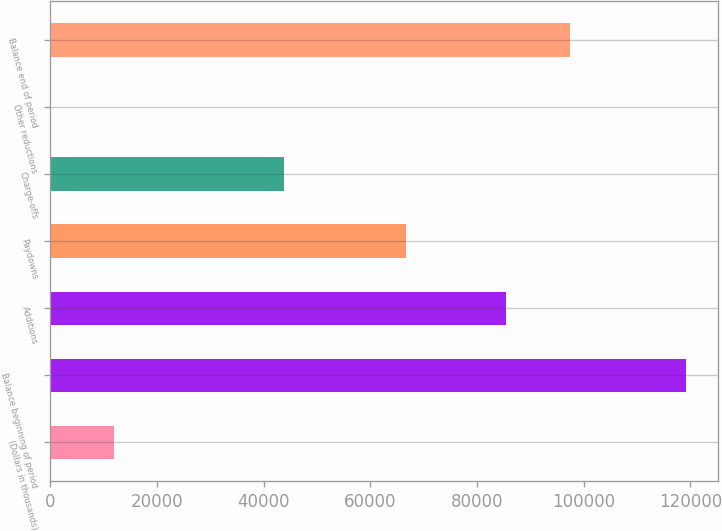Convert chart to OTSL. <chart><loc_0><loc_0><loc_500><loc_500><bar_chart><fcel>(Dollars in thousands)<fcel>Balance beginning of period<fcel>Additions<fcel>Paydowns<fcel>Charge-offs<fcel>Other reductions<fcel>Balance end of period<nl><fcel>12015<fcel>119259<fcel>85499<fcel>66660<fcel>43857<fcel>99<fcel>97415<nl></chart> 